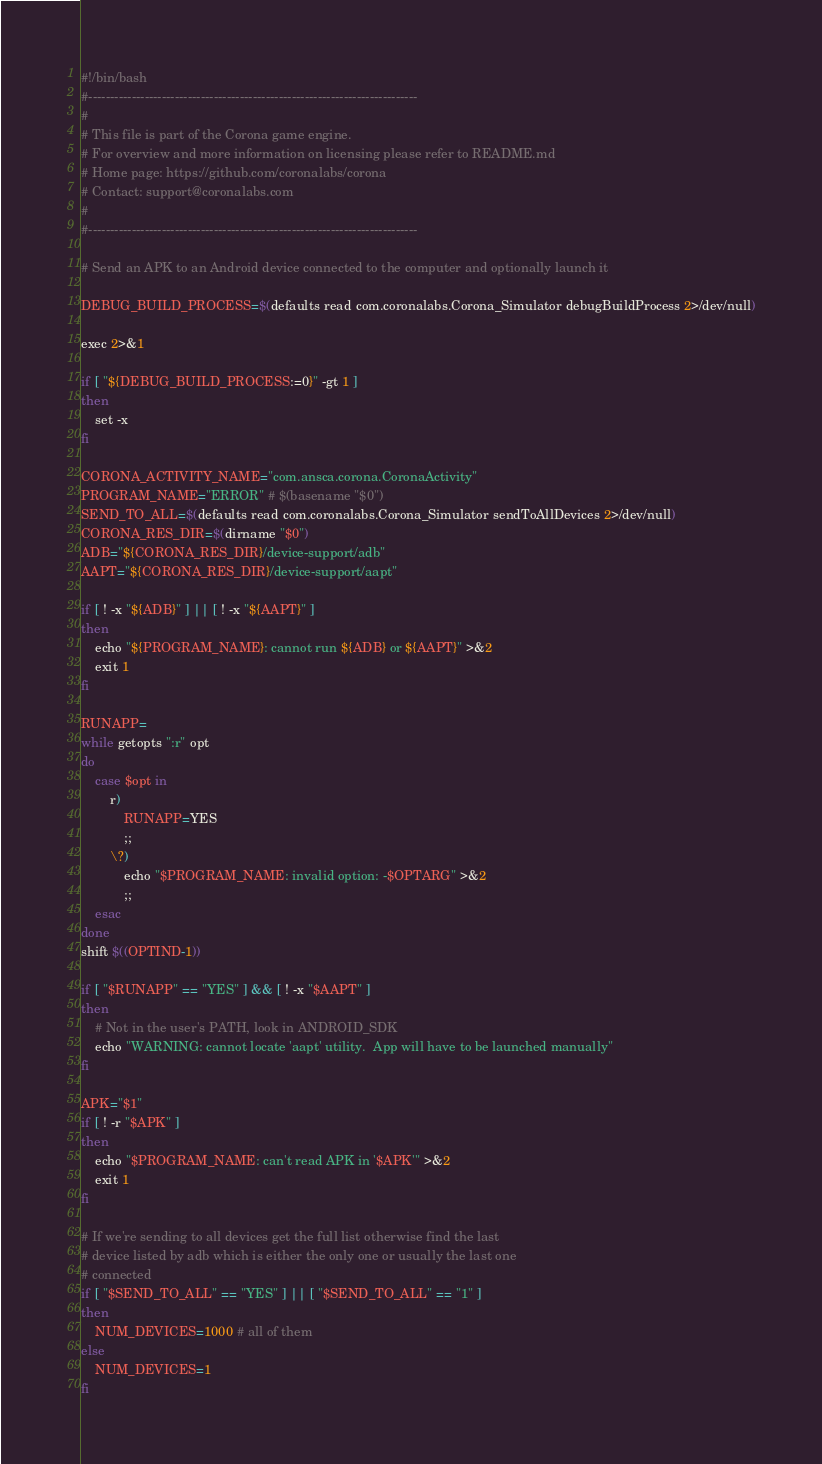Convert code to text. <code><loc_0><loc_0><loc_500><loc_500><_Bash_>#!/bin/bash
#----------------------------------------------------------------------------
#
# This file is part of the Corona game engine.
# For overview and more information on licensing please refer to README.md 
# Home page: https://github.com/coronalabs/corona
# Contact: support@coronalabs.com
#
#----------------------------------------------------------------------------

# Send an APK to an Android device connected to the computer and optionally launch it

DEBUG_BUILD_PROCESS=$(defaults read com.coronalabs.Corona_Simulator debugBuildProcess 2>/dev/null)

exec 2>&1

if [ "${DEBUG_BUILD_PROCESS:=0}" -gt 1 ]
then
	set -x
fi

CORONA_ACTIVITY_NAME="com.ansca.corona.CoronaActivity"
PROGRAM_NAME="ERROR" # $(basename "$0")
SEND_TO_ALL=$(defaults read com.coronalabs.Corona_Simulator sendToAllDevices 2>/dev/null)
CORONA_RES_DIR=$(dirname "$0")
ADB="${CORONA_RES_DIR}/device-support/adb"
AAPT="${CORONA_RES_DIR}/device-support/aapt"

if [ ! -x "${ADB}" ] || [ ! -x "${AAPT}" ]
then
	echo "${PROGRAM_NAME}: cannot run ${ADB} or ${AAPT}" >&2
	exit 1
fi

RUNAPP=
while getopts ":r" opt
do
	case $opt in
		r)
			RUNAPP=YES
			;;
		\?)
			echo "$PROGRAM_NAME: invalid option: -$OPTARG" >&2
			;;
	esac
done
shift $((OPTIND-1))

if [ "$RUNAPP" == "YES" ] && [ ! -x "$AAPT" ]
then
	# Not in the user's PATH, look in ANDROID_SDK
	echo "WARNING: cannot locate 'aapt' utility.  App will have to be launched manually"
fi

APK="$1"
if [ ! -r "$APK" ]
then
	echo "$PROGRAM_NAME: can't read APK in '$APK'" >&2
	exit 1
fi

# If we're sending to all devices get the full list otherwise find the last
# device listed by adb which is either the only one or usually the last one
# connected
if [ "$SEND_TO_ALL" == "YES" ] || [ "$SEND_TO_ALL" == "1" ]
then
	NUM_DEVICES=1000 # all of them
else
	NUM_DEVICES=1
fi
</code> 